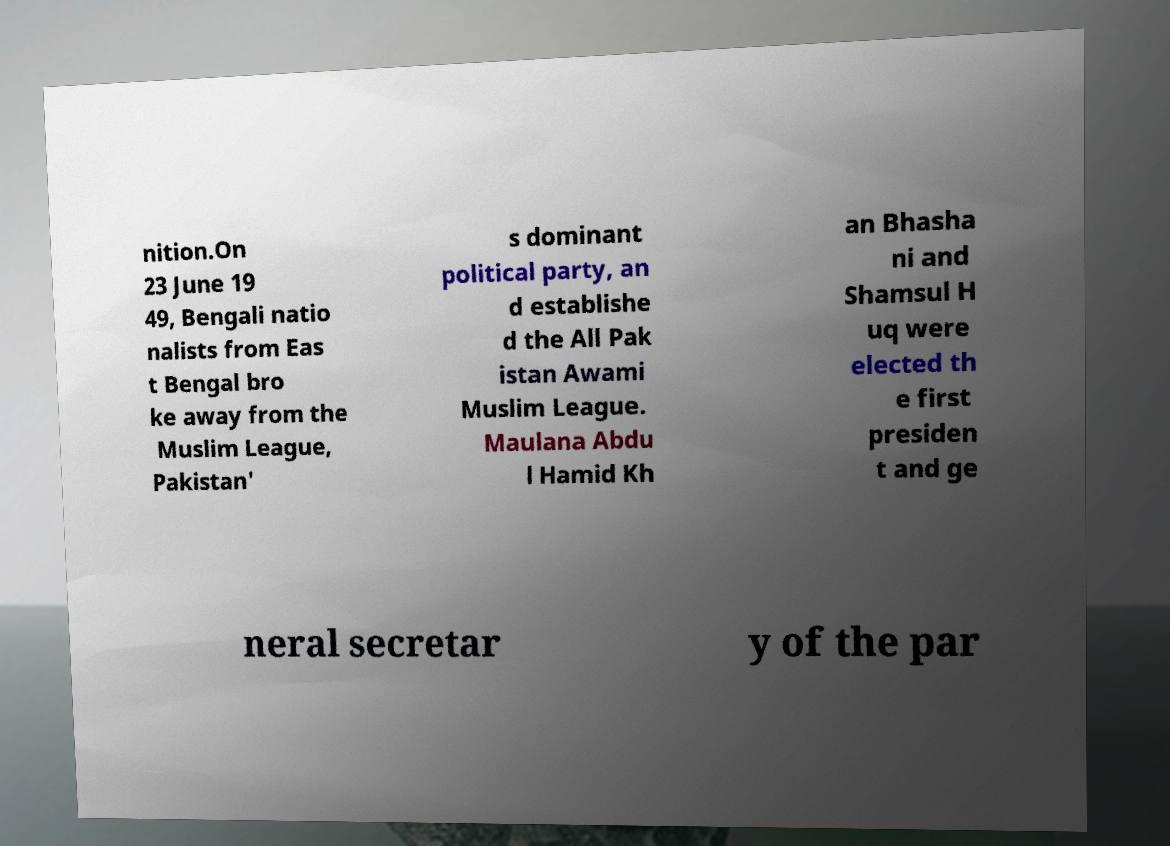Can you read and provide the text displayed in the image?This photo seems to have some interesting text. Can you extract and type it out for me? nition.On 23 June 19 49, Bengali natio nalists from Eas t Bengal bro ke away from the Muslim League, Pakistan' s dominant political party, an d establishe d the All Pak istan Awami Muslim League. Maulana Abdu l Hamid Kh an Bhasha ni and Shamsul H uq were elected th e first presiden t and ge neral secretar y of the par 